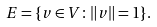Convert formula to latex. <formula><loc_0><loc_0><loc_500><loc_500>E = \{ v \in V \colon \| v \| = 1 \} .</formula> 